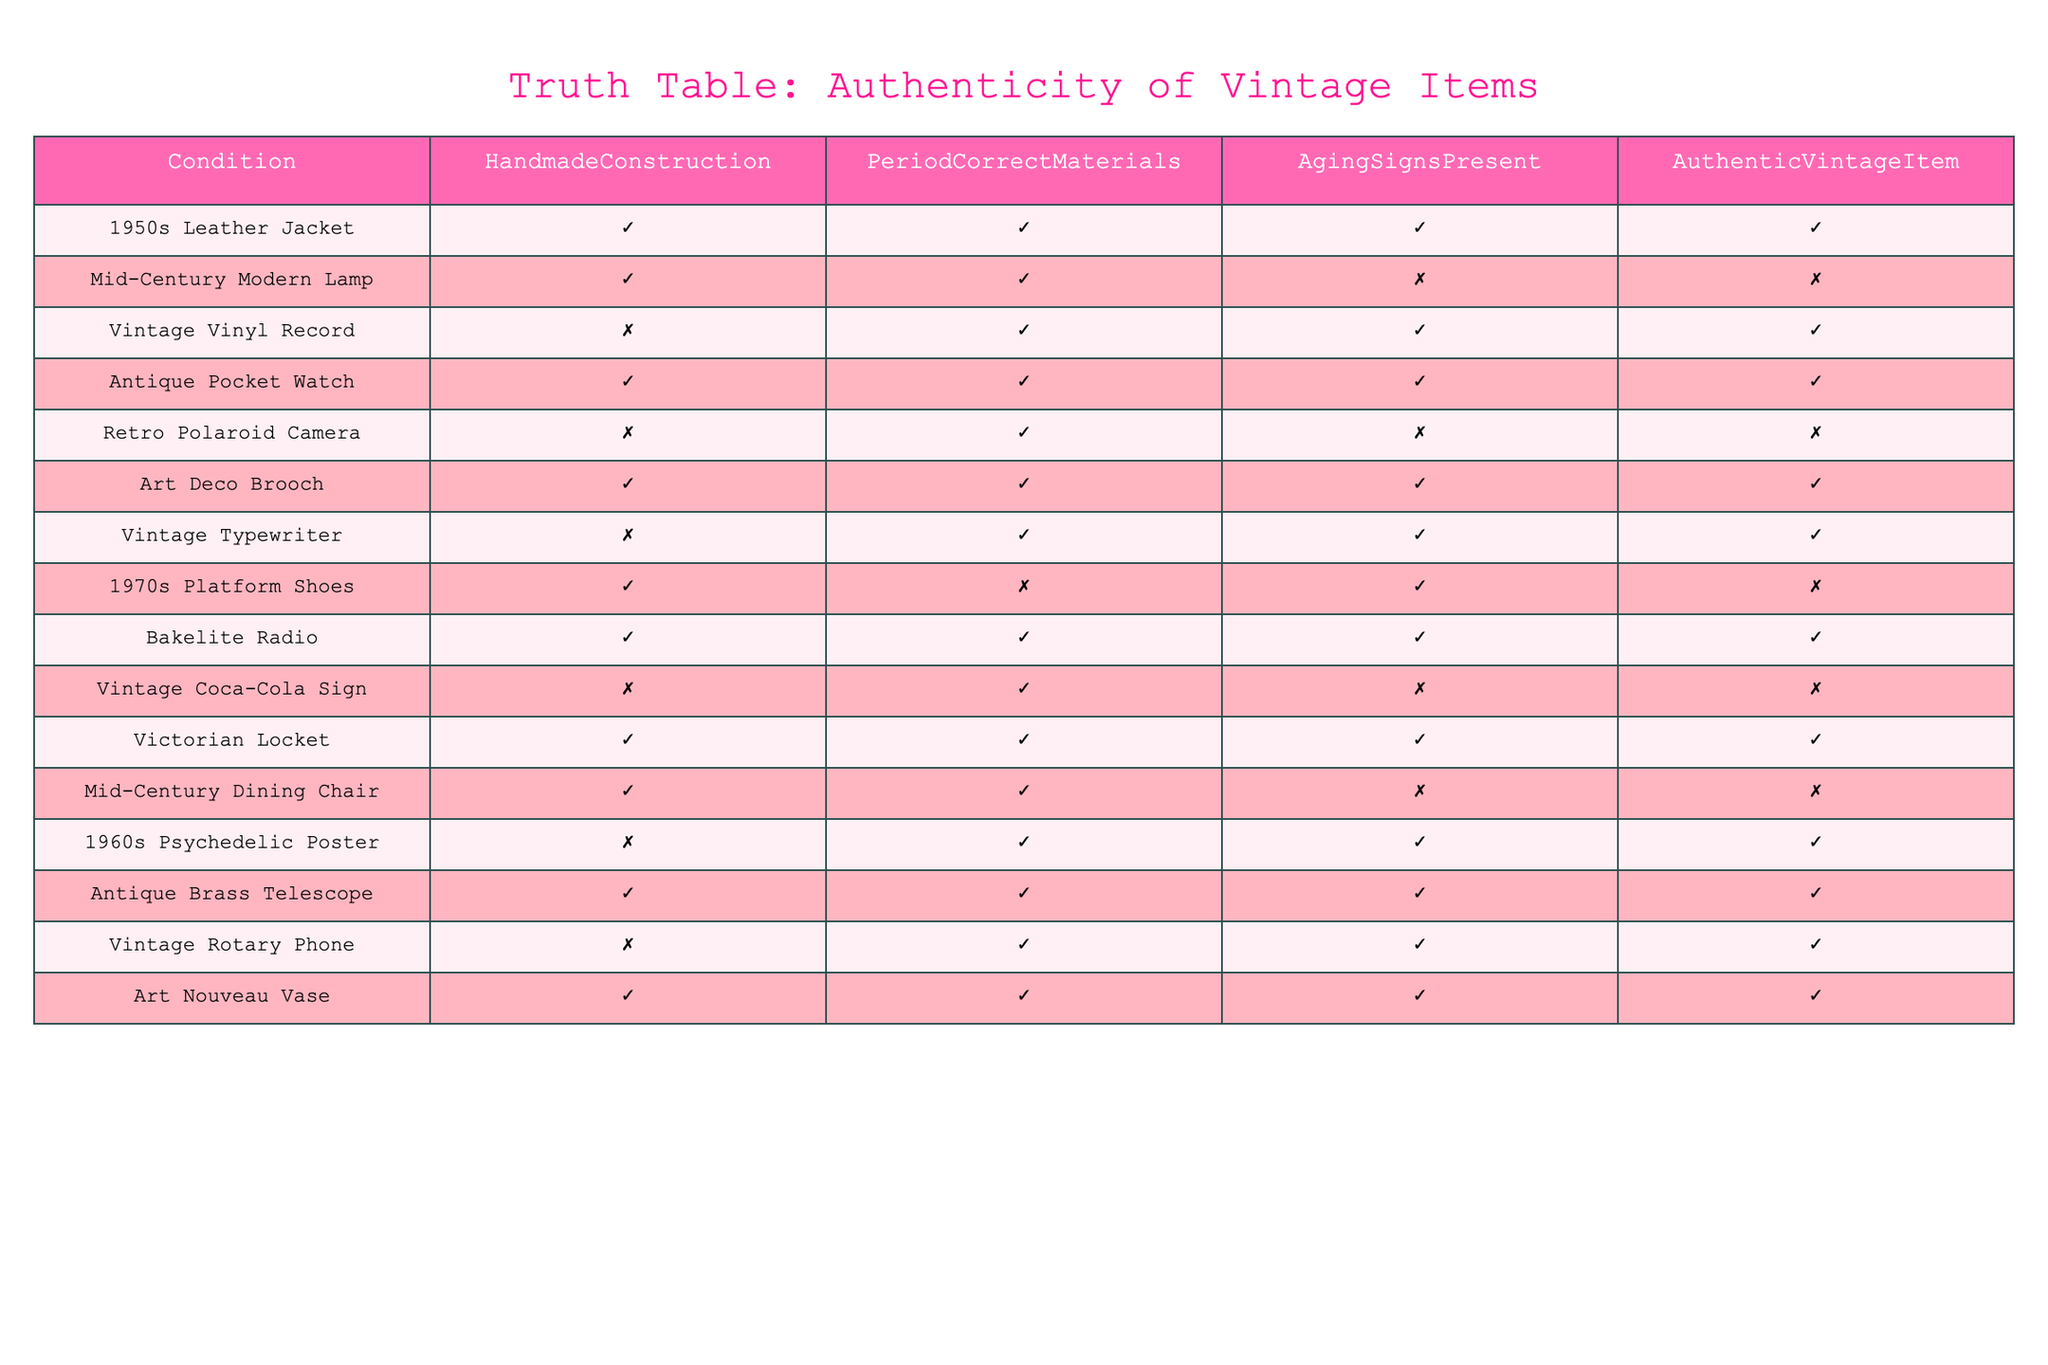What percentage of items listed are authentic vintage items? There are 15 items in total, and 9 of them are marked as authentic vintage items. To find the percentage, I use the formula (number of authentic items / total items) * 100, which gives me (9 / 15) * 100 = 60%.
Answer: 60% Is the Vintage Vinyl Record considered an authentic vintage item? In the table, the Vintage Vinyl Record is marked as an authentic vintage item (TRUE), indicating that it meets the criteria for authenticity.
Answer: Yes How many items have both Handmade Construction and Period Correct Materials? Looking at the table, I can count the items that have both conditions marked as TRUE. The items are: 1950s Leather Jacket, Antique Pocket Watch, Art Deco Brooch, Bakelite Radio, Victorian Locket, Antique Brass Telescope, and Art Nouveau Vase, totaling 7 items.
Answer: 7 Which item has aging signs present but is still not considered an authentic vintage item? I check the Aging Signs Present column and look for items where it’s TRUE, but the Authentic Vintage Item column is FALSE. The item that fits this description is the Mid-Century Modern Lamp.
Answer: Mid-Century Modern Lamp What is the total number of items that are marked as authentic vintage items and also show signs of aging? I need to identify items that are marked TRUE for both Authentic Vintage Item and Aging Signs Present. The items that meet this condition are: 1950s Leather Jacket, Vintage Vinyl Record, Antique Pocket Watch, Art Deco Brooch, Vintage Typewriter, 1960s Psychedelic Poster, Vintage Rotary Phone, and Art Nouveau Vase, which totals to 8 items.
Answer: 8 Is there any item that is not handmade but still considered an authentic vintage item? I look for items that are marked as FALSE under Handmade Construction and check if they are authentic. The Vintage Vinyl Record and Vintage Typewriter meet this criterion as they are not handmade but marked as authentic.
Answer: Yes, Vintage Vinyl Record and Vintage Typewriter How many items do not meet the criteria for authenticity because they are missing either Handmade Construction or Aging Signs? I check each item in the table, looking for items where either Handmade Construction or Aging Signs Present is marked as FALSE. The following items do not meet the criteria: Mid-Century Modern Lamp, Retro Polaroid Camera, 1970s Platform Shoes, Vintage Coca-Cola Sign, and Mid-Century Dining Chair, totaling 5 items.
Answer: 5 What is the ratio of authentic vintage items to non-authentic vintage items? I have 9 authentic vintage items and 6 non-authentic items. To find the ratio, I divide the number of authentic items by the number of non-authentic items: 9:6, which simplifies to 3:2.
Answer: 3:2 